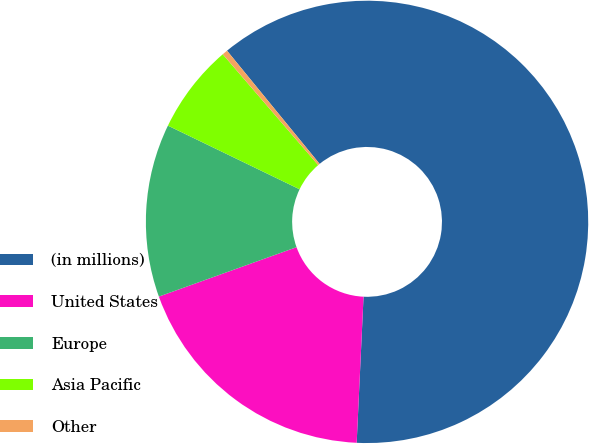<chart> <loc_0><loc_0><loc_500><loc_500><pie_chart><fcel>(in millions)<fcel>United States<fcel>Europe<fcel>Asia Pacific<fcel>Other<nl><fcel>61.66%<fcel>18.77%<fcel>12.65%<fcel>6.52%<fcel>0.4%<nl></chart> 